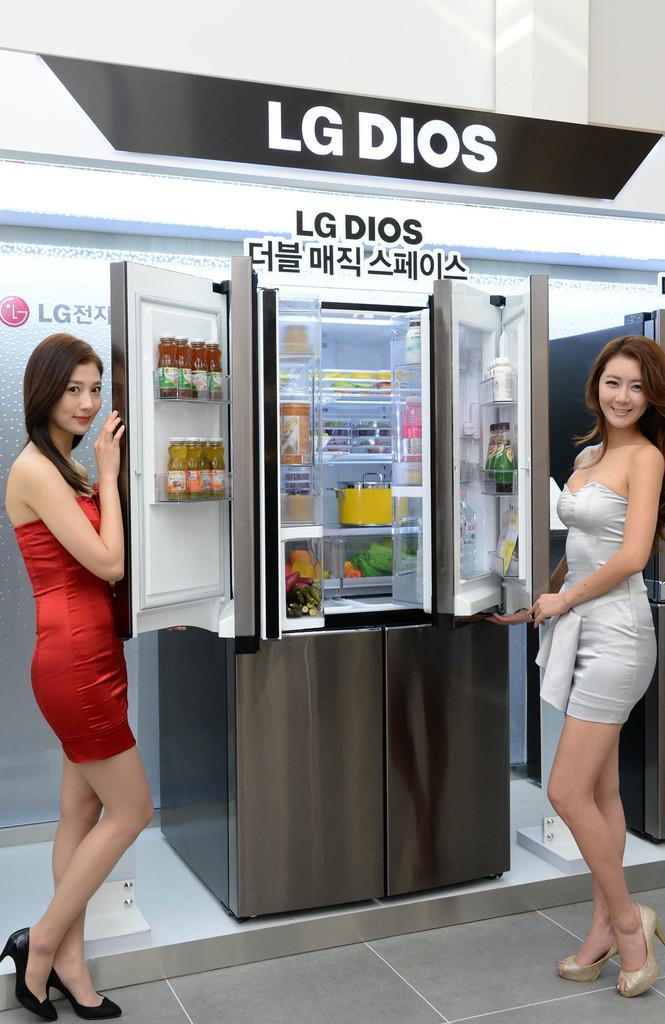<image>
Present a compact description of the photo's key features. a banner above a fridge that says 'lg dios' on it 